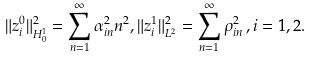Convert formula to latex. <formula><loc_0><loc_0><loc_500><loc_500>\| z _ { i } ^ { 0 } \| ^ { 2 } _ { H ^ { 1 } _ { 0 } } = \sum _ { n = 1 } ^ { \infty } \alpha ^ { 2 } _ { i n } n ^ { 2 } , \| z _ { i } ^ { 1 } \| ^ { 2 } _ { L ^ { 2 } } = \sum _ { n = 1 } ^ { \infty } \rho ^ { 2 } _ { i n } \, , i = 1 , 2 .</formula> 